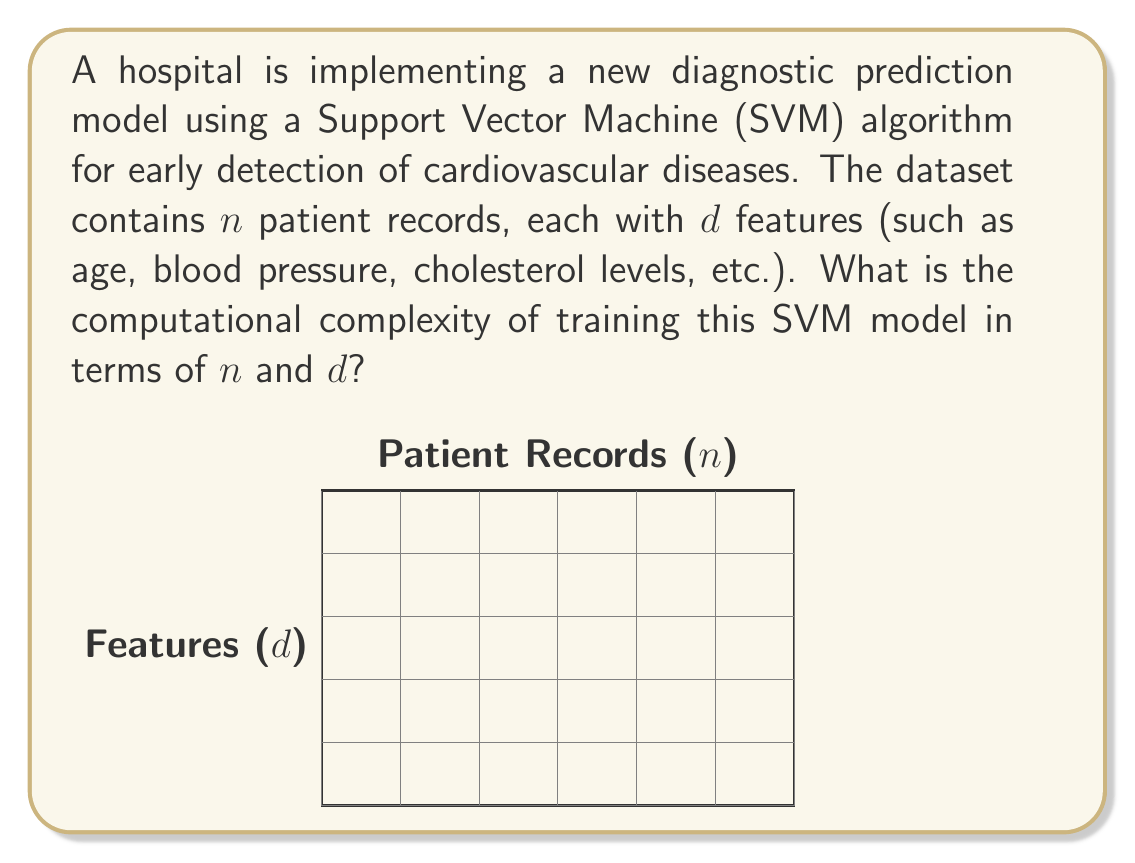Can you solve this math problem? To determine the computational complexity of training an SVM model, we need to consider the following steps:

1) The standard SVM algorithm solves a quadratic programming (QP) problem.

2) The QP problem involves an $n \times n$ kernel matrix, where $n$ is the number of training samples.

3) For each element of this matrix, we need to compute the kernel function between two $d$-dimensional feature vectors.

4) The computation of each kernel function (typically a dot product) takes $O(d)$ time.

5) Therefore, constructing the entire kernel matrix takes $O(n^2d)$ time.

6) Solving the QP problem using standard algorithms (like the interior point method) typically has a complexity of $O(n^3)$.

7) Combining these, we get a total complexity of $O(n^2d + n^3)$.

8) However, in practice, $d$ is usually much smaller than $n$, so we can simplify this to $O(n^3)$.

9) It's worth noting that there are more efficient SVM implementations, like Sequential Minimal Optimization (SMO), which can reduce the complexity to approximately $O(n^2)$ or even $O(n)$ for some datasets.

For our medical diagnostic scenario, where we might have a large number of patient records but a relatively small number of features, the $O(n^3)$ complexity of the standard SVM algorithm could be a limiting factor for very large datasets. This highlights the importance of algorithm selection and optimization in medical machine learning applications.
Answer: $O(n^3)$ 